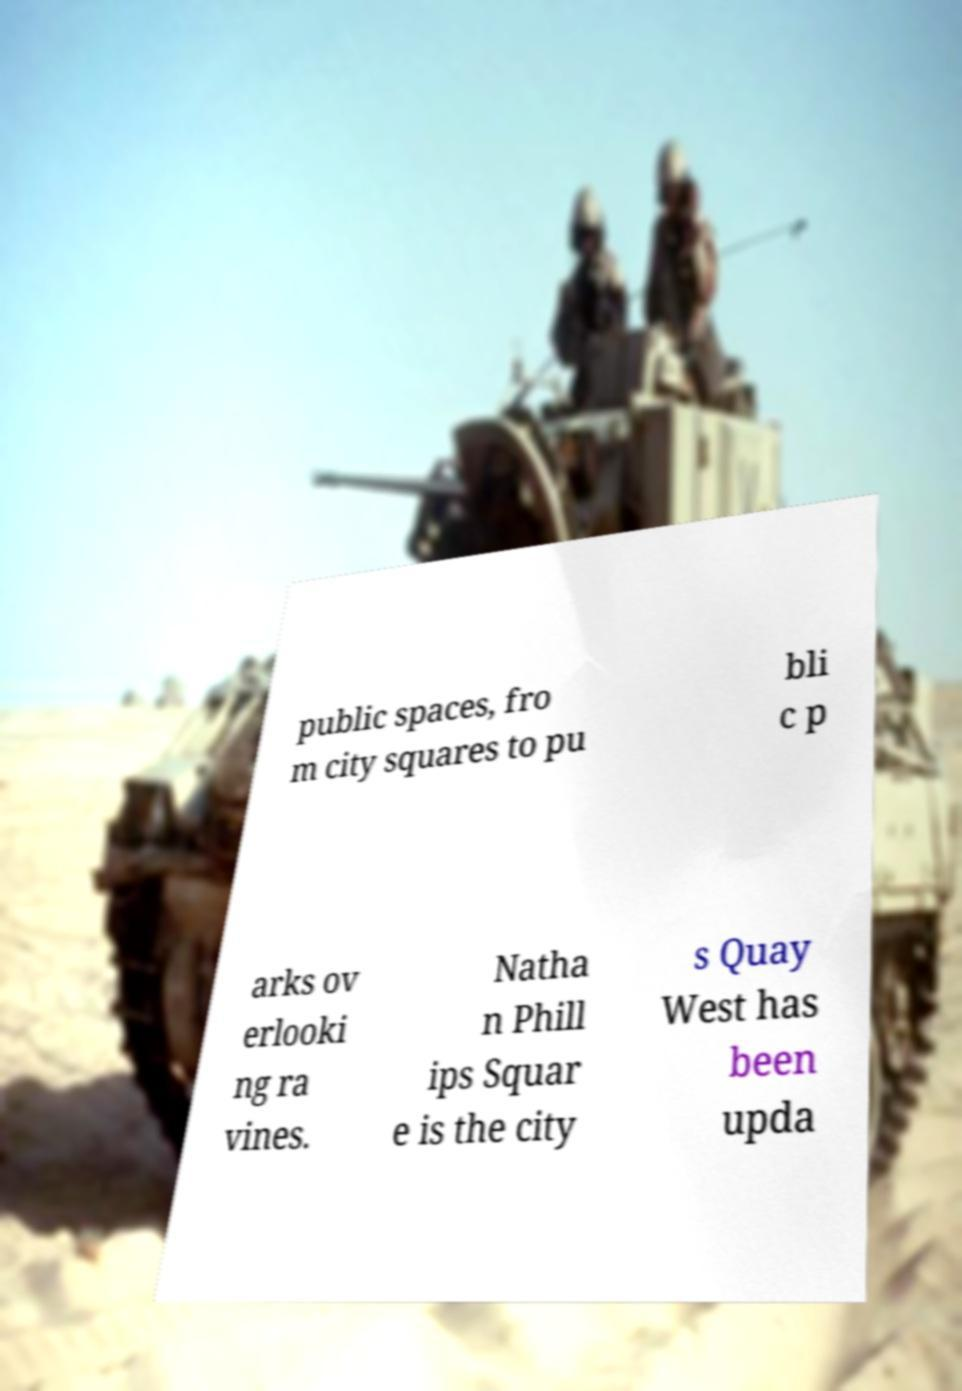What messages or text are displayed in this image? I need them in a readable, typed format. public spaces, fro m city squares to pu bli c p arks ov erlooki ng ra vines. Natha n Phill ips Squar e is the city s Quay West has been upda 